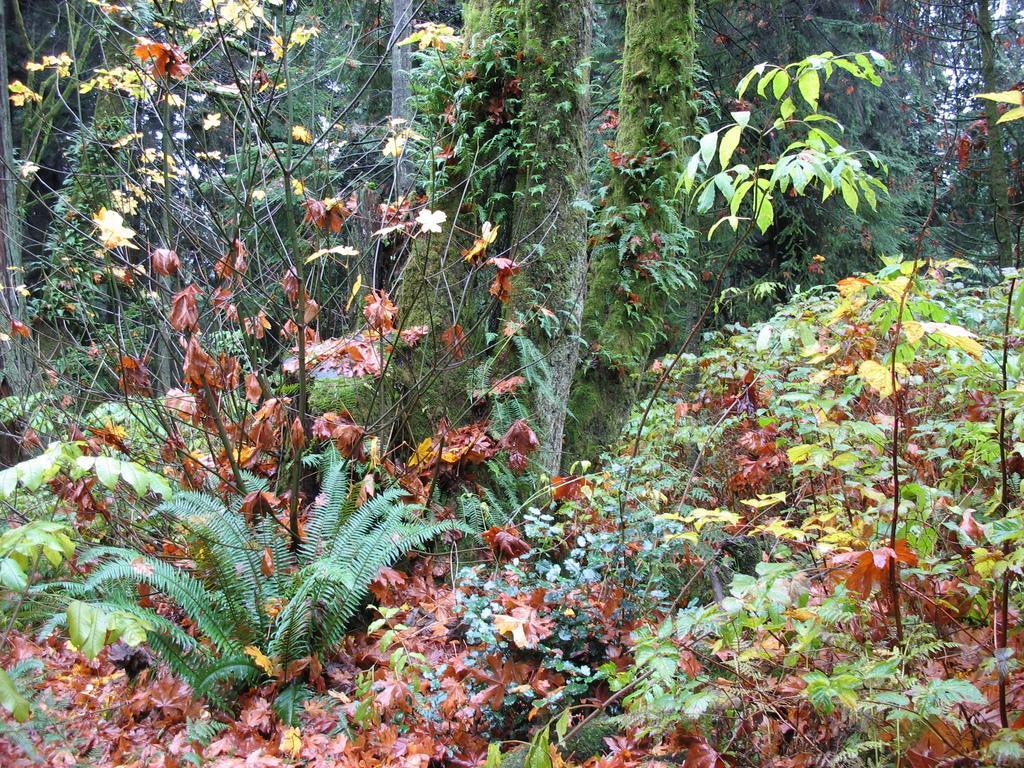Could you give a brief overview of what you see in this image? In this picture I can see plants in the foreground. I can see trees in the background. 